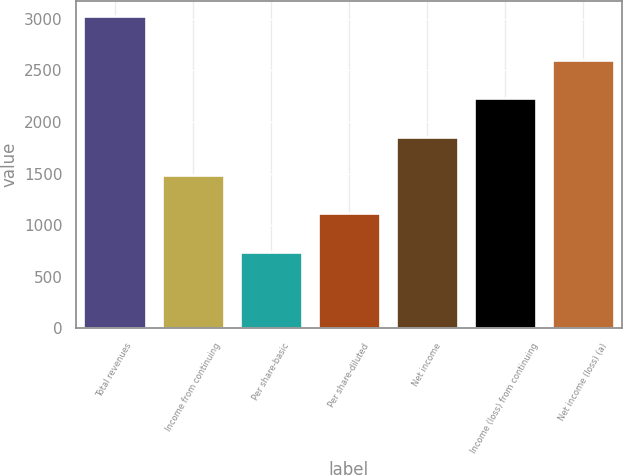Convert chart to OTSL. <chart><loc_0><loc_0><loc_500><loc_500><bar_chart><fcel>Total revenues<fcel>Income from continuing<fcel>Per share-basic<fcel>Per share-diluted<fcel>Net income<fcel>Income (loss) from continuing<fcel>Net income (loss) (a)<nl><fcel>3023<fcel>1485.79<fcel>743.39<fcel>1114.59<fcel>1856.99<fcel>2228.19<fcel>2599.39<nl></chart> 